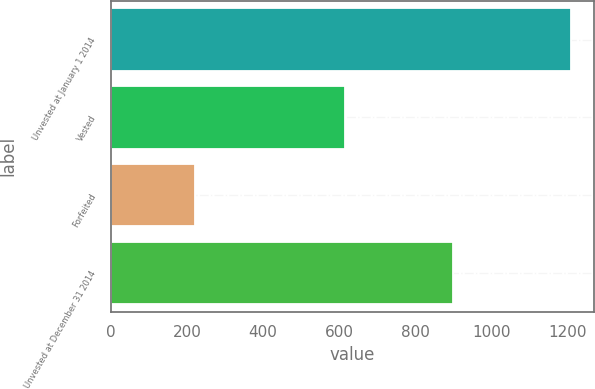Convert chart to OTSL. <chart><loc_0><loc_0><loc_500><loc_500><bar_chart><fcel>Unvested at January 1 2014<fcel>Vested<fcel>Forfeited<fcel>Unvested at December 31 2014<nl><fcel>1208<fcel>614<fcel>222<fcel>900<nl></chart> 